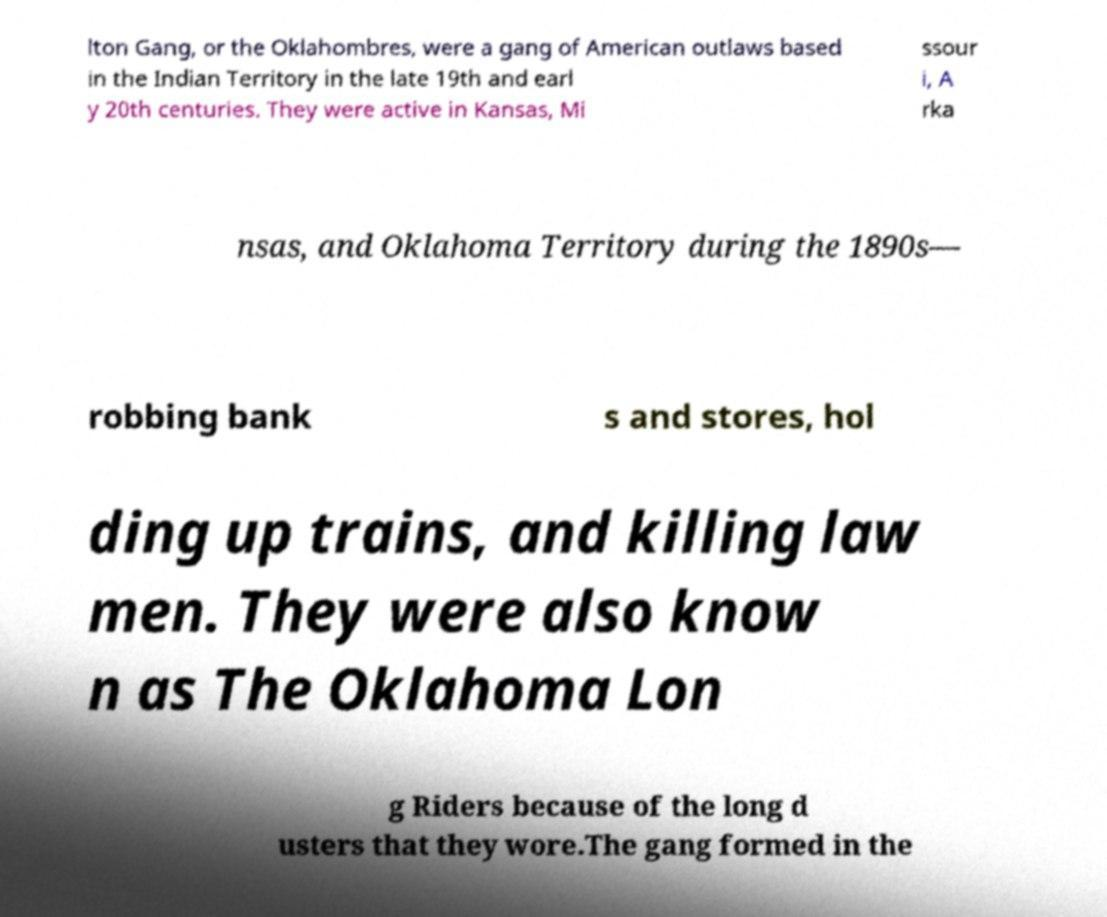For documentation purposes, I need the text within this image transcribed. Could you provide that? lton Gang, or the Oklahombres, were a gang of American outlaws based in the Indian Territory in the late 19th and earl y 20th centuries. They were active in Kansas, Mi ssour i, A rka nsas, and Oklahoma Territory during the 1890s— robbing bank s and stores, hol ding up trains, and killing law men. They were also know n as The Oklahoma Lon g Riders because of the long d usters that they wore.The gang formed in the 